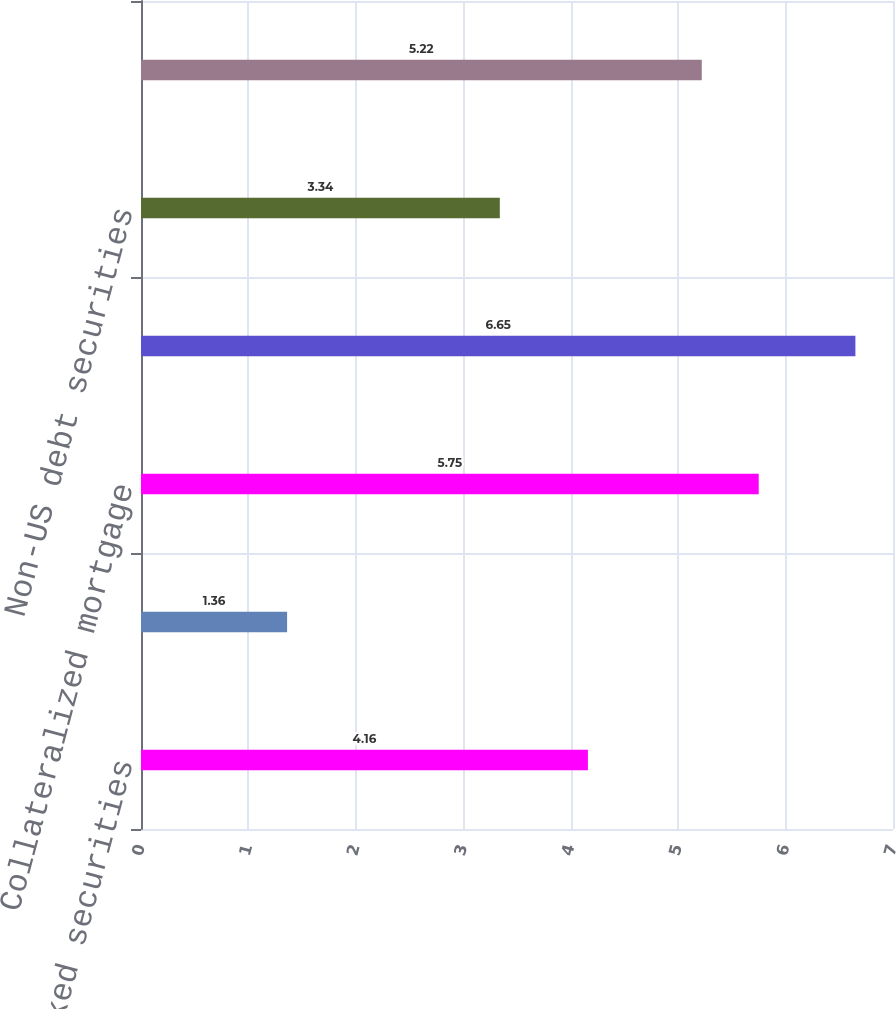<chart> <loc_0><loc_0><loc_500><loc_500><bar_chart><fcel>Mortgage-backed securities<fcel>Asset-backed securities<fcel>Collateralized mortgage<fcel>State and political<fcel>Non-US debt securities<fcel>Other debt securities<nl><fcel>4.16<fcel>1.36<fcel>5.75<fcel>6.65<fcel>3.34<fcel>5.22<nl></chart> 